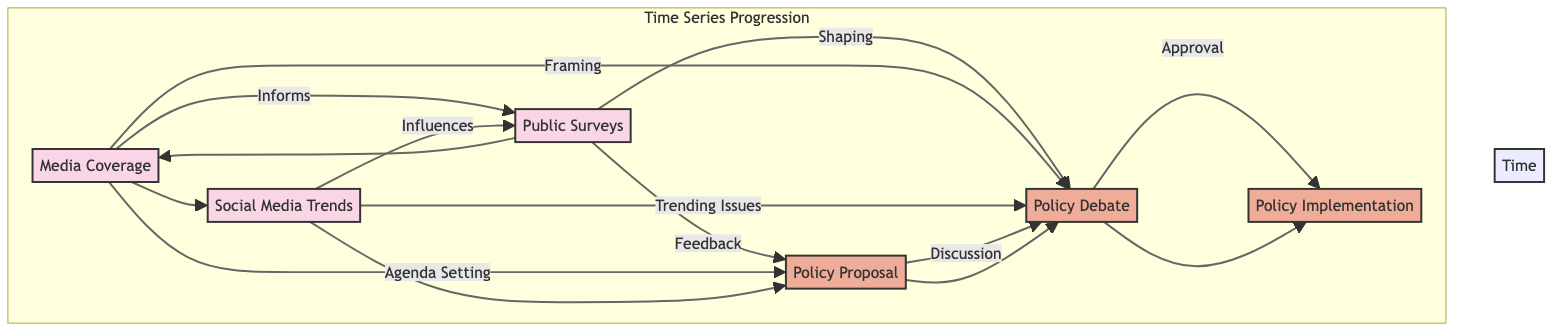What are the three sources of public opinion shown in the diagram? The diagram highlights three sources of public opinion: Media Coverage, Public Surveys, and Social Media Trends. These are clearly labeled as nodes in the visual representation.
Answer: Media Coverage, Public Surveys, Social Media Trends How many nodes are present in the diagram? Upon counting the nodes displayed in the diagram, we find seven distinct nodes in total: three opinion nodes and four policy nodes.
Answer: Seven What is the role of Social Media Trends in the diagram? Social Media Trends influences Public Surveys and helps identify Trending Issues, which connect to the Policy Debate. This is indicated by the directed edges connecting these nodes.
Answer: Influences Public Surveys Which node ultimately leads to Policy Implementation? The flow from the diagram shows that the Policy Debate node leads to Policy Implementation, as this is where the discussion ends with an approval that initiates the implementation phase.
Answer: Policy Debate What is the relationship between Media Coverage and Policy Proposal? The diagram illustrates that Media Coverage plays an agenda-setting role for Policy Proposals, suggesting that it impacts what policies are considered. The directed edge emanating from Media Coverage supports this relationship.
Answer: Agenda Setting What is the direction of the flow from Public Surveys to Policy Proposal? The flow diagram indicates that Public Surveys provide feedback to shape Policy Proposals, indicating a direct influence of public sentiment on policy suggestion processes.
Answer: Feedback Which opinion source is connected to shaping Policy Debate? The diagram shows that Public Surveys help shape the Policy Debate, indicated by a directed edge pointing from Public Surveys to Policy Debate.
Answer: Public Surveys What type of diagram elements are used to represent public opinion and policy nodes? The public opinion nodes are represented as pink, and the policy nodes are shown in orange, clearly differentiating between the sources of opinion and the stages of policy development in the diagram.
Answer: Colors (Pink and Orange) How does the diagram represent the progression of time? The diagram employs a subgraph labeled "Time Series Progression" with a left-to-right direction indicating a chronological sequence from Public Surveys through to Policy Implementation, demonstrating the progression in time as it relates to policy decisions.
Answer: Subgraph labeled "Time Series Progression" 